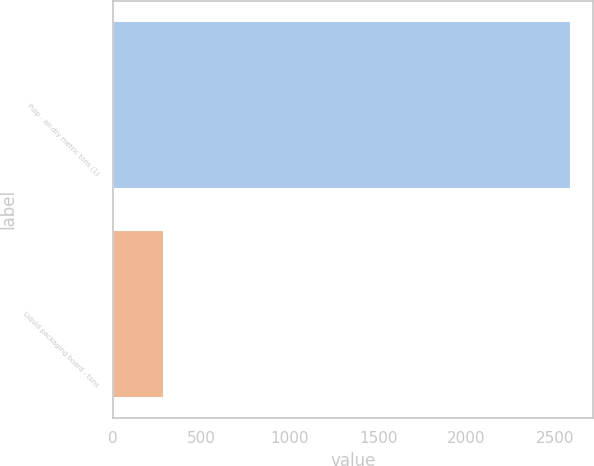Convert chart. <chart><loc_0><loc_0><loc_500><loc_500><bar_chart><fcel>Pulp - air-dry metric tons (1)<fcel>Liquid packaging board - tons<nl><fcel>2588<fcel>282<nl></chart> 